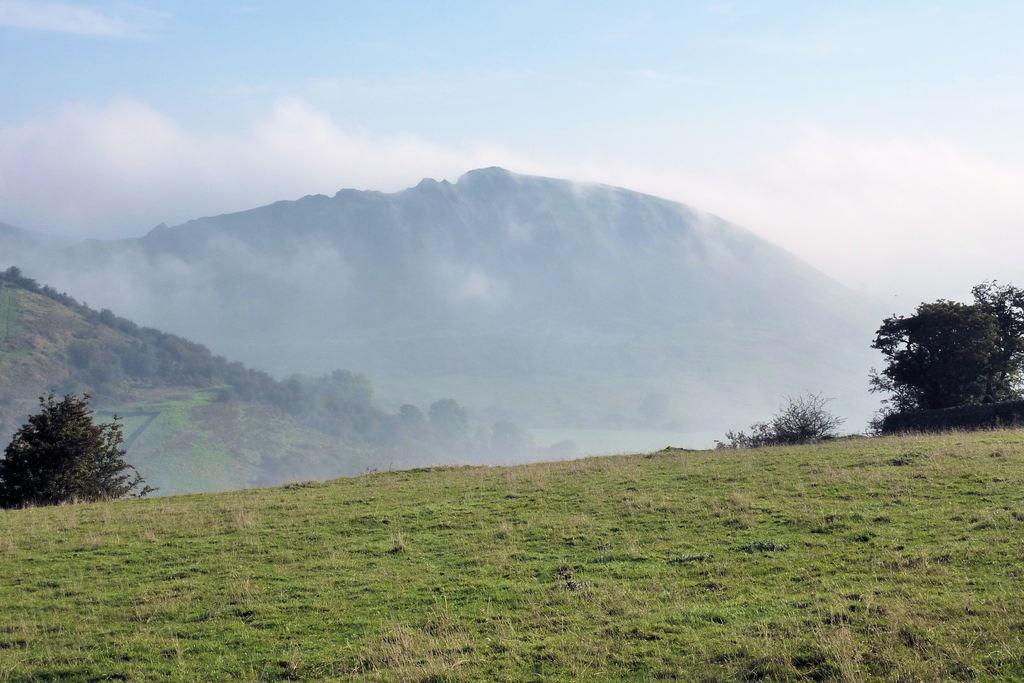Could you give a brief overview of what you see in this image? This picture is clicked outside. In the foreground we can see the green grass. In the center we can see the plants and the rocks. In the background we can see the sky and the fog. 